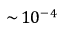<formula> <loc_0><loc_0><loc_500><loc_500>\sim \, 1 0 ^ { - 4 }</formula> 